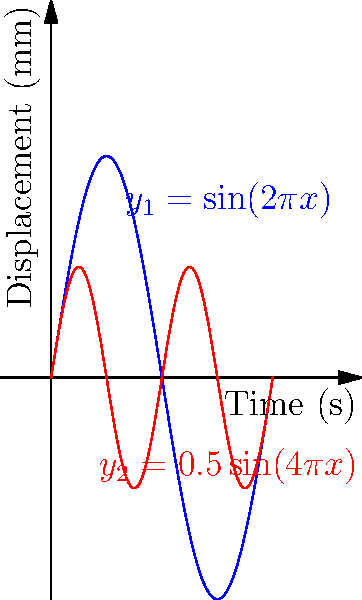The graph shows two sinusoidal functions representing the vibration patterns of vocal cords. The blue curve is described by $y_1 = \sin(2\pi x)$ and the red curve by $y_2 = 0.5\sin(4\pi x)$, where $x$ is time in seconds and $y$ is displacement in millimeters. At what time $t$ in the interval $[0, 1]$ do these two functions first intersect? To find the intersection point, we need to solve the equation:

$$\sin(2\pi x) = 0.5\sin(4\pi x)$$

Let's approach this step-by-step:

1) First, recall the trigonometric identity: $\sin(2\theta) = 2\sin(\theta)\cos(\theta)$

2) Apply this to the right side of our equation:
   $$\sin(2\pi x) = 0.5[2\sin(2\pi x)\cos(2\pi x)]$$

3) Simplify:
   $$\sin(2\pi x) = \sin(2\pi x)\cos(2\pi x)$$

4) Subtract $\sin(2\pi x)$ from both sides:
   $$0 = \sin(2\pi x)[\cos(2\pi x) - 1]$$

5) This equation is satisfied when either $\sin(2\pi x) = 0$ or $\cos(2\pi x) = 1$

6) $\sin(2\pi x) = 0$ when $x = 0, 0.5, 1, ...$
   $\cos(2\pi x) = 1$ when $x = 0, 1, 2, ...$

7) In the interval $[0, 1]$, the first non-zero solution is $x = 0.25$

8) Verify: 
   At $x = 0.25$, $\sin(2\pi(0.25)) = \sin(\pi/2) = 1$
   and $0.5\sin(4\pi(0.25)) = 0.5\sin(\pi) = 0.5$

Therefore, the functions first intersect at $t = 0.25$ seconds.
Answer: 0.25 seconds 